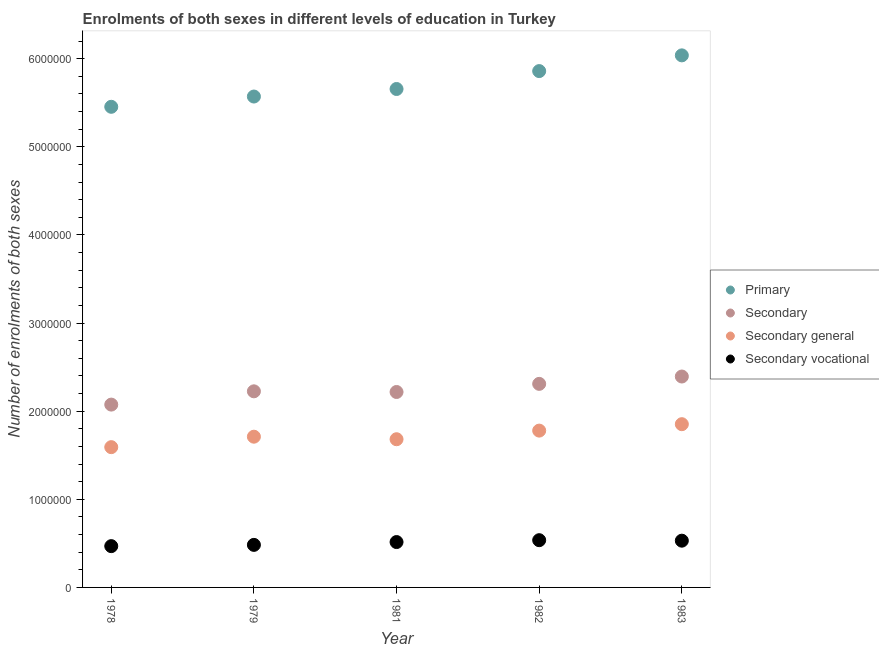How many different coloured dotlines are there?
Offer a very short reply. 4. Is the number of dotlines equal to the number of legend labels?
Make the answer very short. Yes. What is the number of enrolments in primary education in 1981?
Ensure brevity in your answer.  5.66e+06. Across all years, what is the maximum number of enrolments in primary education?
Give a very brief answer. 6.04e+06. Across all years, what is the minimum number of enrolments in secondary vocational education?
Your response must be concise. 4.69e+05. In which year was the number of enrolments in secondary education minimum?
Offer a terse response. 1978. What is the total number of enrolments in primary education in the graph?
Keep it short and to the point. 2.86e+07. What is the difference between the number of enrolments in secondary vocational education in 1978 and that in 1983?
Offer a very short reply. -6.19e+04. What is the difference between the number of enrolments in secondary vocational education in 1979 and the number of enrolments in secondary education in 1981?
Ensure brevity in your answer.  -1.74e+06. What is the average number of enrolments in secondary general education per year?
Your answer should be compact. 1.72e+06. In the year 1983, what is the difference between the number of enrolments in secondary education and number of enrolments in primary education?
Ensure brevity in your answer.  -3.64e+06. In how many years, is the number of enrolments in secondary vocational education greater than 1200000?
Make the answer very short. 0. What is the ratio of the number of enrolments in secondary vocational education in 1979 to that in 1982?
Give a very brief answer. 0.9. Is the difference between the number of enrolments in secondary vocational education in 1979 and 1982 greater than the difference between the number of enrolments in secondary education in 1979 and 1982?
Keep it short and to the point. Yes. What is the difference between the highest and the second highest number of enrolments in secondary general education?
Provide a succinct answer. 7.29e+04. What is the difference between the highest and the lowest number of enrolments in secondary vocational education?
Your answer should be compact. 6.75e+04. Is the sum of the number of enrolments in primary education in 1979 and 1982 greater than the maximum number of enrolments in secondary education across all years?
Your answer should be compact. Yes. Is the number of enrolments in secondary education strictly less than the number of enrolments in secondary general education over the years?
Give a very brief answer. No. How many years are there in the graph?
Provide a short and direct response. 5. Does the graph contain grids?
Keep it short and to the point. No. Where does the legend appear in the graph?
Your response must be concise. Center right. How many legend labels are there?
Your answer should be compact. 4. What is the title of the graph?
Provide a short and direct response. Enrolments of both sexes in different levels of education in Turkey. Does "Portugal" appear as one of the legend labels in the graph?
Keep it short and to the point. No. What is the label or title of the X-axis?
Give a very brief answer. Year. What is the label or title of the Y-axis?
Keep it short and to the point. Number of enrolments of both sexes. What is the Number of enrolments of both sexes in Primary in 1978?
Make the answer very short. 5.45e+06. What is the Number of enrolments of both sexes of Secondary in 1978?
Your response must be concise. 2.07e+06. What is the Number of enrolments of both sexes of Secondary general in 1978?
Offer a terse response. 1.59e+06. What is the Number of enrolments of both sexes in Secondary vocational in 1978?
Your answer should be very brief. 4.69e+05. What is the Number of enrolments of both sexes in Primary in 1979?
Your answer should be compact. 5.57e+06. What is the Number of enrolments of both sexes in Secondary in 1979?
Your response must be concise. 2.23e+06. What is the Number of enrolments of both sexes in Secondary general in 1979?
Offer a very short reply. 1.71e+06. What is the Number of enrolments of both sexes in Secondary vocational in 1979?
Provide a succinct answer. 4.83e+05. What is the Number of enrolments of both sexes of Primary in 1981?
Your answer should be very brief. 5.66e+06. What is the Number of enrolments of both sexes in Secondary in 1981?
Your response must be concise. 2.22e+06. What is the Number of enrolments of both sexes in Secondary general in 1981?
Your answer should be very brief. 1.68e+06. What is the Number of enrolments of both sexes in Secondary vocational in 1981?
Offer a very short reply. 5.15e+05. What is the Number of enrolments of both sexes in Primary in 1982?
Make the answer very short. 5.86e+06. What is the Number of enrolments of both sexes of Secondary in 1982?
Keep it short and to the point. 2.31e+06. What is the Number of enrolments of both sexes in Secondary general in 1982?
Provide a short and direct response. 1.78e+06. What is the Number of enrolments of both sexes in Secondary vocational in 1982?
Offer a very short reply. 5.36e+05. What is the Number of enrolments of both sexes of Primary in 1983?
Make the answer very short. 6.04e+06. What is the Number of enrolments of both sexes in Secondary in 1983?
Offer a very short reply. 2.39e+06. What is the Number of enrolments of both sexes in Secondary general in 1983?
Offer a terse response. 1.85e+06. What is the Number of enrolments of both sexes of Secondary vocational in 1983?
Provide a short and direct response. 5.30e+05. Across all years, what is the maximum Number of enrolments of both sexes in Primary?
Keep it short and to the point. 6.04e+06. Across all years, what is the maximum Number of enrolments of both sexes of Secondary?
Ensure brevity in your answer.  2.39e+06. Across all years, what is the maximum Number of enrolments of both sexes in Secondary general?
Your answer should be compact. 1.85e+06. Across all years, what is the maximum Number of enrolments of both sexes in Secondary vocational?
Offer a very short reply. 5.36e+05. Across all years, what is the minimum Number of enrolments of both sexes of Primary?
Your answer should be very brief. 5.45e+06. Across all years, what is the minimum Number of enrolments of both sexes in Secondary?
Your answer should be compact. 2.07e+06. Across all years, what is the minimum Number of enrolments of both sexes of Secondary general?
Keep it short and to the point. 1.59e+06. Across all years, what is the minimum Number of enrolments of both sexes of Secondary vocational?
Ensure brevity in your answer.  4.69e+05. What is the total Number of enrolments of both sexes in Primary in the graph?
Offer a very short reply. 2.86e+07. What is the total Number of enrolments of both sexes of Secondary in the graph?
Provide a short and direct response. 1.12e+07. What is the total Number of enrolments of both sexes of Secondary general in the graph?
Your answer should be very brief. 8.62e+06. What is the total Number of enrolments of both sexes of Secondary vocational in the graph?
Make the answer very short. 2.53e+06. What is the difference between the Number of enrolments of both sexes of Primary in 1978 and that in 1979?
Your answer should be compact. -1.17e+05. What is the difference between the Number of enrolments of both sexes of Secondary in 1978 and that in 1979?
Your response must be concise. -1.51e+05. What is the difference between the Number of enrolments of both sexes of Secondary general in 1978 and that in 1979?
Your answer should be compact. -1.19e+05. What is the difference between the Number of enrolments of both sexes of Secondary vocational in 1978 and that in 1979?
Your answer should be very brief. -1.43e+04. What is the difference between the Number of enrolments of both sexes of Primary in 1978 and that in 1981?
Offer a terse response. -2.02e+05. What is the difference between the Number of enrolments of both sexes in Secondary in 1978 and that in 1981?
Your answer should be compact. -1.43e+05. What is the difference between the Number of enrolments of both sexes of Secondary general in 1978 and that in 1981?
Make the answer very short. -8.99e+04. What is the difference between the Number of enrolments of both sexes in Secondary vocational in 1978 and that in 1981?
Provide a succinct answer. -4.64e+04. What is the difference between the Number of enrolments of both sexes in Primary in 1978 and that in 1982?
Offer a very short reply. -4.05e+05. What is the difference between the Number of enrolments of both sexes of Secondary in 1978 and that in 1982?
Offer a very short reply. -2.35e+05. What is the difference between the Number of enrolments of both sexes in Secondary general in 1978 and that in 1982?
Your answer should be compact. -1.88e+05. What is the difference between the Number of enrolments of both sexes of Secondary vocational in 1978 and that in 1982?
Provide a short and direct response. -6.75e+04. What is the difference between the Number of enrolments of both sexes of Primary in 1978 and that in 1983?
Give a very brief answer. -5.84e+05. What is the difference between the Number of enrolments of both sexes of Secondary in 1978 and that in 1983?
Offer a terse response. -3.19e+05. What is the difference between the Number of enrolments of both sexes of Secondary general in 1978 and that in 1983?
Your answer should be very brief. -2.61e+05. What is the difference between the Number of enrolments of both sexes in Secondary vocational in 1978 and that in 1983?
Make the answer very short. -6.19e+04. What is the difference between the Number of enrolments of both sexes of Primary in 1979 and that in 1981?
Offer a terse response. -8.56e+04. What is the difference between the Number of enrolments of both sexes of Secondary in 1979 and that in 1981?
Make the answer very short. 7624. What is the difference between the Number of enrolments of both sexes of Secondary general in 1979 and that in 1981?
Give a very brief answer. 2.88e+04. What is the difference between the Number of enrolments of both sexes of Secondary vocational in 1979 and that in 1981?
Offer a very short reply. -3.20e+04. What is the difference between the Number of enrolments of both sexes of Primary in 1979 and that in 1982?
Ensure brevity in your answer.  -2.89e+05. What is the difference between the Number of enrolments of both sexes of Secondary in 1979 and that in 1982?
Give a very brief answer. -8.46e+04. What is the difference between the Number of enrolments of both sexes in Secondary general in 1979 and that in 1982?
Your response must be concise. -6.90e+04. What is the difference between the Number of enrolments of both sexes of Secondary vocational in 1979 and that in 1982?
Provide a succinct answer. -5.32e+04. What is the difference between the Number of enrolments of both sexes of Primary in 1979 and that in 1983?
Give a very brief answer. -4.67e+05. What is the difference between the Number of enrolments of both sexes in Secondary in 1979 and that in 1983?
Provide a short and direct response. -1.68e+05. What is the difference between the Number of enrolments of both sexes in Secondary general in 1979 and that in 1983?
Make the answer very short. -1.42e+05. What is the difference between the Number of enrolments of both sexes in Secondary vocational in 1979 and that in 1983?
Your answer should be compact. -4.76e+04. What is the difference between the Number of enrolments of both sexes of Primary in 1981 and that in 1982?
Offer a very short reply. -2.03e+05. What is the difference between the Number of enrolments of both sexes in Secondary in 1981 and that in 1982?
Give a very brief answer. -9.22e+04. What is the difference between the Number of enrolments of both sexes of Secondary general in 1981 and that in 1982?
Provide a succinct answer. -9.78e+04. What is the difference between the Number of enrolments of both sexes of Secondary vocational in 1981 and that in 1982?
Make the answer very short. -2.12e+04. What is the difference between the Number of enrolments of both sexes in Primary in 1981 and that in 1983?
Offer a terse response. -3.82e+05. What is the difference between the Number of enrolments of both sexes of Secondary in 1981 and that in 1983?
Give a very brief answer. -1.76e+05. What is the difference between the Number of enrolments of both sexes of Secondary general in 1981 and that in 1983?
Ensure brevity in your answer.  -1.71e+05. What is the difference between the Number of enrolments of both sexes in Secondary vocational in 1981 and that in 1983?
Provide a short and direct response. -1.56e+04. What is the difference between the Number of enrolments of both sexes of Primary in 1982 and that in 1983?
Offer a very short reply. -1.78e+05. What is the difference between the Number of enrolments of both sexes in Secondary in 1982 and that in 1983?
Provide a short and direct response. -8.34e+04. What is the difference between the Number of enrolments of both sexes of Secondary general in 1982 and that in 1983?
Make the answer very short. -7.29e+04. What is the difference between the Number of enrolments of both sexes of Secondary vocational in 1982 and that in 1983?
Your answer should be compact. 5622. What is the difference between the Number of enrolments of both sexes in Primary in 1978 and the Number of enrolments of both sexes in Secondary in 1979?
Provide a succinct answer. 3.23e+06. What is the difference between the Number of enrolments of both sexes of Primary in 1978 and the Number of enrolments of both sexes of Secondary general in 1979?
Give a very brief answer. 3.74e+06. What is the difference between the Number of enrolments of both sexes of Primary in 1978 and the Number of enrolments of both sexes of Secondary vocational in 1979?
Your answer should be very brief. 4.97e+06. What is the difference between the Number of enrolments of both sexes in Secondary in 1978 and the Number of enrolments of both sexes in Secondary general in 1979?
Your answer should be very brief. 3.64e+05. What is the difference between the Number of enrolments of both sexes in Secondary in 1978 and the Number of enrolments of both sexes in Secondary vocational in 1979?
Your answer should be very brief. 1.59e+06. What is the difference between the Number of enrolments of both sexes of Secondary general in 1978 and the Number of enrolments of both sexes of Secondary vocational in 1979?
Offer a very short reply. 1.11e+06. What is the difference between the Number of enrolments of both sexes in Primary in 1978 and the Number of enrolments of both sexes in Secondary in 1981?
Ensure brevity in your answer.  3.24e+06. What is the difference between the Number of enrolments of both sexes in Primary in 1978 and the Number of enrolments of both sexes in Secondary general in 1981?
Offer a terse response. 3.77e+06. What is the difference between the Number of enrolments of both sexes in Primary in 1978 and the Number of enrolments of both sexes in Secondary vocational in 1981?
Provide a succinct answer. 4.94e+06. What is the difference between the Number of enrolments of both sexes in Secondary in 1978 and the Number of enrolments of both sexes in Secondary general in 1981?
Offer a terse response. 3.93e+05. What is the difference between the Number of enrolments of both sexes of Secondary in 1978 and the Number of enrolments of both sexes of Secondary vocational in 1981?
Make the answer very short. 1.56e+06. What is the difference between the Number of enrolments of both sexes in Secondary general in 1978 and the Number of enrolments of both sexes in Secondary vocational in 1981?
Provide a short and direct response. 1.08e+06. What is the difference between the Number of enrolments of both sexes in Primary in 1978 and the Number of enrolments of both sexes in Secondary in 1982?
Your answer should be compact. 3.14e+06. What is the difference between the Number of enrolments of both sexes in Primary in 1978 and the Number of enrolments of both sexes in Secondary general in 1982?
Your response must be concise. 3.67e+06. What is the difference between the Number of enrolments of both sexes in Primary in 1978 and the Number of enrolments of both sexes in Secondary vocational in 1982?
Your answer should be very brief. 4.92e+06. What is the difference between the Number of enrolments of both sexes in Secondary in 1978 and the Number of enrolments of both sexes in Secondary general in 1982?
Your answer should be compact. 2.95e+05. What is the difference between the Number of enrolments of both sexes of Secondary in 1978 and the Number of enrolments of both sexes of Secondary vocational in 1982?
Give a very brief answer. 1.54e+06. What is the difference between the Number of enrolments of both sexes in Secondary general in 1978 and the Number of enrolments of both sexes in Secondary vocational in 1982?
Provide a short and direct response. 1.06e+06. What is the difference between the Number of enrolments of both sexes in Primary in 1978 and the Number of enrolments of both sexes in Secondary in 1983?
Your answer should be compact. 3.06e+06. What is the difference between the Number of enrolments of both sexes in Primary in 1978 and the Number of enrolments of both sexes in Secondary general in 1983?
Make the answer very short. 3.60e+06. What is the difference between the Number of enrolments of both sexes in Primary in 1978 and the Number of enrolments of both sexes in Secondary vocational in 1983?
Provide a succinct answer. 4.92e+06. What is the difference between the Number of enrolments of both sexes of Secondary in 1978 and the Number of enrolments of both sexes of Secondary general in 1983?
Offer a very short reply. 2.22e+05. What is the difference between the Number of enrolments of both sexes in Secondary in 1978 and the Number of enrolments of both sexes in Secondary vocational in 1983?
Provide a succinct answer. 1.54e+06. What is the difference between the Number of enrolments of both sexes of Secondary general in 1978 and the Number of enrolments of both sexes of Secondary vocational in 1983?
Your response must be concise. 1.06e+06. What is the difference between the Number of enrolments of both sexes of Primary in 1979 and the Number of enrolments of both sexes of Secondary in 1981?
Offer a very short reply. 3.35e+06. What is the difference between the Number of enrolments of both sexes in Primary in 1979 and the Number of enrolments of both sexes in Secondary general in 1981?
Provide a succinct answer. 3.89e+06. What is the difference between the Number of enrolments of both sexes of Primary in 1979 and the Number of enrolments of both sexes of Secondary vocational in 1981?
Offer a terse response. 5.06e+06. What is the difference between the Number of enrolments of both sexes of Secondary in 1979 and the Number of enrolments of both sexes of Secondary general in 1981?
Keep it short and to the point. 5.44e+05. What is the difference between the Number of enrolments of both sexes in Secondary in 1979 and the Number of enrolments of both sexes in Secondary vocational in 1981?
Your response must be concise. 1.71e+06. What is the difference between the Number of enrolments of both sexes of Secondary general in 1979 and the Number of enrolments of both sexes of Secondary vocational in 1981?
Your answer should be compact. 1.20e+06. What is the difference between the Number of enrolments of both sexes of Primary in 1979 and the Number of enrolments of both sexes of Secondary in 1982?
Provide a short and direct response. 3.26e+06. What is the difference between the Number of enrolments of both sexes in Primary in 1979 and the Number of enrolments of both sexes in Secondary general in 1982?
Ensure brevity in your answer.  3.79e+06. What is the difference between the Number of enrolments of both sexes of Primary in 1979 and the Number of enrolments of both sexes of Secondary vocational in 1982?
Your answer should be compact. 5.03e+06. What is the difference between the Number of enrolments of both sexes in Secondary in 1979 and the Number of enrolments of both sexes in Secondary general in 1982?
Your response must be concise. 4.46e+05. What is the difference between the Number of enrolments of both sexes of Secondary in 1979 and the Number of enrolments of both sexes of Secondary vocational in 1982?
Ensure brevity in your answer.  1.69e+06. What is the difference between the Number of enrolments of both sexes of Secondary general in 1979 and the Number of enrolments of both sexes of Secondary vocational in 1982?
Keep it short and to the point. 1.17e+06. What is the difference between the Number of enrolments of both sexes of Primary in 1979 and the Number of enrolments of both sexes of Secondary in 1983?
Offer a very short reply. 3.18e+06. What is the difference between the Number of enrolments of both sexes of Primary in 1979 and the Number of enrolments of both sexes of Secondary general in 1983?
Your response must be concise. 3.72e+06. What is the difference between the Number of enrolments of both sexes in Primary in 1979 and the Number of enrolments of both sexes in Secondary vocational in 1983?
Provide a succinct answer. 5.04e+06. What is the difference between the Number of enrolments of both sexes in Secondary in 1979 and the Number of enrolments of both sexes in Secondary general in 1983?
Make the answer very short. 3.73e+05. What is the difference between the Number of enrolments of both sexes in Secondary in 1979 and the Number of enrolments of both sexes in Secondary vocational in 1983?
Give a very brief answer. 1.70e+06. What is the difference between the Number of enrolments of both sexes of Secondary general in 1979 and the Number of enrolments of both sexes of Secondary vocational in 1983?
Give a very brief answer. 1.18e+06. What is the difference between the Number of enrolments of both sexes in Primary in 1981 and the Number of enrolments of both sexes in Secondary in 1982?
Offer a terse response. 3.35e+06. What is the difference between the Number of enrolments of both sexes of Primary in 1981 and the Number of enrolments of both sexes of Secondary general in 1982?
Make the answer very short. 3.88e+06. What is the difference between the Number of enrolments of both sexes in Primary in 1981 and the Number of enrolments of both sexes in Secondary vocational in 1982?
Keep it short and to the point. 5.12e+06. What is the difference between the Number of enrolments of both sexes of Secondary in 1981 and the Number of enrolments of both sexes of Secondary general in 1982?
Your answer should be compact. 4.38e+05. What is the difference between the Number of enrolments of both sexes of Secondary in 1981 and the Number of enrolments of both sexes of Secondary vocational in 1982?
Provide a succinct answer. 1.68e+06. What is the difference between the Number of enrolments of both sexes in Secondary general in 1981 and the Number of enrolments of both sexes in Secondary vocational in 1982?
Provide a succinct answer. 1.15e+06. What is the difference between the Number of enrolments of both sexes in Primary in 1981 and the Number of enrolments of both sexes in Secondary in 1983?
Provide a short and direct response. 3.26e+06. What is the difference between the Number of enrolments of both sexes in Primary in 1981 and the Number of enrolments of both sexes in Secondary general in 1983?
Provide a short and direct response. 3.80e+06. What is the difference between the Number of enrolments of both sexes in Primary in 1981 and the Number of enrolments of both sexes in Secondary vocational in 1983?
Give a very brief answer. 5.13e+06. What is the difference between the Number of enrolments of both sexes of Secondary in 1981 and the Number of enrolments of both sexes of Secondary general in 1983?
Ensure brevity in your answer.  3.65e+05. What is the difference between the Number of enrolments of both sexes of Secondary in 1981 and the Number of enrolments of both sexes of Secondary vocational in 1983?
Ensure brevity in your answer.  1.69e+06. What is the difference between the Number of enrolments of both sexes in Secondary general in 1981 and the Number of enrolments of both sexes in Secondary vocational in 1983?
Your response must be concise. 1.15e+06. What is the difference between the Number of enrolments of both sexes in Primary in 1982 and the Number of enrolments of both sexes in Secondary in 1983?
Your answer should be compact. 3.47e+06. What is the difference between the Number of enrolments of both sexes of Primary in 1982 and the Number of enrolments of both sexes of Secondary general in 1983?
Keep it short and to the point. 4.01e+06. What is the difference between the Number of enrolments of both sexes in Primary in 1982 and the Number of enrolments of both sexes in Secondary vocational in 1983?
Provide a short and direct response. 5.33e+06. What is the difference between the Number of enrolments of both sexes in Secondary in 1982 and the Number of enrolments of both sexes in Secondary general in 1983?
Offer a very short reply. 4.58e+05. What is the difference between the Number of enrolments of both sexes in Secondary in 1982 and the Number of enrolments of both sexes in Secondary vocational in 1983?
Offer a terse response. 1.78e+06. What is the difference between the Number of enrolments of both sexes in Secondary general in 1982 and the Number of enrolments of both sexes in Secondary vocational in 1983?
Ensure brevity in your answer.  1.25e+06. What is the average Number of enrolments of both sexes in Primary per year?
Your answer should be compact. 5.72e+06. What is the average Number of enrolments of both sexes in Secondary per year?
Your answer should be very brief. 2.24e+06. What is the average Number of enrolments of both sexes in Secondary general per year?
Provide a succinct answer. 1.72e+06. What is the average Number of enrolments of both sexes of Secondary vocational per year?
Your response must be concise. 5.07e+05. In the year 1978, what is the difference between the Number of enrolments of both sexes in Primary and Number of enrolments of both sexes in Secondary?
Offer a terse response. 3.38e+06. In the year 1978, what is the difference between the Number of enrolments of both sexes in Primary and Number of enrolments of both sexes in Secondary general?
Ensure brevity in your answer.  3.86e+06. In the year 1978, what is the difference between the Number of enrolments of both sexes of Primary and Number of enrolments of both sexes of Secondary vocational?
Offer a very short reply. 4.99e+06. In the year 1978, what is the difference between the Number of enrolments of both sexes in Secondary and Number of enrolments of both sexes in Secondary general?
Your answer should be compact. 4.83e+05. In the year 1978, what is the difference between the Number of enrolments of both sexes of Secondary and Number of enrolments of both sexes of Secondary vocational?
Your answer should be very brief. 1.61e+06. In the year 1978, what is the difference between the Number of enrolments of both sexes of Secondary general and Number of enrolments of both sexes of Secondary vocational?
Give a very brief answer. 1.12e+06. In the year 1979, what is the difference between the Number of enrolments of both sexes of Primary and Number of enrolments of both sexes of Secondary?
Your response must be concise. 3.35e+06. In the year 1979, what is the difference between the Number of enrolments of both sexes in Primary and Number of enrolments of both sexes in Secondary general?
Ensure brevity in your answer.  3.86e+06. In the year 1979, what is the difference between the Number of enrolments of both sexes of Primary and Number of enrolments of both sexes of Secondary vocational?
Offer a terse response. 5.09e+06. In the year 1979, what is the difference between the Number of enrolments of both sexes in Secondary and Number of enrolments of both sexes in Secondary general?
Your answer should be compact. 5.15e+05. In the year 1979, what is the difference between the Number of enrolments of both sexes in Secondary and Number of enrolments of both sexes in Secondary vocational?
Your answer should be very brief. 1.74e+06. In the year 1979, what is the difference between the Number of enrolments of both sexes of Secondary general and Number of enrolments of both sexes of Secondary vocational?
Make the answer very short. 1.23e+06. In the year 1981, what is the difference between the Number of enrolments of both sexes of Primary and Number of enrolments of both sexes of Secondary?
Keep it short and to the point. 3.44e+06. In the year 1981, what is the difference between the Number of enrolments of both sexes in Primary and Number of enrolments of both sexes in Secondary general?
Make the answer very short. 3.97e+06. In the year 1981, what is the difference between the Number of enrolments of both sexes in Primary and Number of enrolments of both sexes in Secondary vocational?
Give a very brief answer. 5.14e+06. In the year 1981, what is the difference between the Number of enrolments of both sexes in Secondary and Number of enrolments of both sexes in Secondary general?
Your response must be concise. 5.36e+05. In the year 1981, what is the difference between the Number of enrolments of both sexes of Secondary and Number of enrolments of both sexes of Secondary vocational?
Provide a short and direct response. 1.70e+06. In the year 1981, what is the difference between the Number of enrolments of both sexes in Secondary general and Number of enrolments of both sexes in Secondary vocational?
Ensure brevity in your answer.  1.17e+06. In the year 1982, what is the difference between the Number of enrolments of both sexes in Primary and Number of enrolments of both sexes in Secondary?
Offer a very short reply. 3.55e+06. In the year 1982, what is the difference between the Number of enrolments of both sexes of Primary and Number of enrolments of both sexes of Secondary general?
Your response must be concise. 4.08e+06. In the year 1982, what is the difference between the Number of enrolments of both sexes of Primary and Number of enrolments of both sexes of Secondary vocational?
Ensure brevity in your answer.  5.32e+06. In the year 1982, what is the difference between the Number of enrolments of both sexes in Secondary and Number of enrolments of both sexes in Secondary general?
Your answer should be compact. 5.30e+05. In the year 1982, what is the difference between the Number of enrolments of both sexes of Secondary and Number of enrolments of both sexes of Secondary vocational?
Provide a succinct answer. 1.77e+06. In the year 1982, what is the difference between the Number of enrolments of both sexes of Secondary general and Number of enrolments of both sexes of Secondary vocational?
Make the answer very short. 1.24e+06. In the year 1983, what is the difference between the Number of enrolments of both sexes in Primary and Number of enrolments of both sexes in Secondary?
Offer a very short reply. 3.64e+06. In the year 1983, what is the difference between the Number of enrolments of both sexes in Primary and Number of enrolments of both sexes in Secondary general?
Keep it short and to the point. 4.19e+06. In the year 1983, what is the difference between the Number of enrolments of both sexes of Primary and Number of enrolments of both sexes of Secondary vocational?
Offer a terse response. 5.51e+06. In the year 1983, what is the difference between the Number of enrolments of both sexes in Secondary and Number of enrolments of both sexes in Secondary general?
Your answer should be very brief. 5.41e+05. In the year 1983, what is the difference between the Number of enrolments of both sexes in Secondary and Number of enrolments of both sexes in Secondary vocational?
Your answer should be very brief. 1.86e+06. In the year 1983, what is the difference between the Number of enrolments of both sexes in Secondary general and Number of enrolments of both sexes in Secondary vocational?
Provide a short and direct response. 1.32e+06. What is the ratio of the Number of enrolments of both sexes of Primary in 1978 to that in 1979?
Offer a terse response. 0.98. What is the ratio of the Number of enrolments of both sexes of Secondary in 1978 to that in 1979?
Offer a terse response. 0.93. What is the ratio of the Number of enrolments of both sexes of Secondary general in 1978 to that in 1979?
Provide a short and direct response. 0.93. What is the ratio of the Number of enrolments of both sexes of Secondary vocational in 1978 to that in 1979?
Offer a very short reply. 0.97. What is the ratio of the Number of enrolments of both sexes of Secondary in 1978 to that in 1981?
Give a very brief answer. 0.94. What is the ratio of the Number of enrolments of both sexes of Secondary general in 1978 to that in 1981?
Provide a succinct answer. 0.95. What is the ratio of the Number of enrolments of both sexes of Secondary vocational in 1978 to that in 1981?
Your answer should be very brief. 0.91. What is the ratio of the Number of enrolments of both sexes of Primary in 1978 to that in 1982?
Your answer should be compact. 0.93. What is the ratio of the Number of enrolments of both sexes of Secondary in 1978 to that in 1982?
Provide a succinct answer. 0.9. What is the ratio of the Number of enrolments of both sexes of Secondary general in 1978 to that in 1982?
Keep it short and to the point. 0.89. What is the ratio of the Number of enrolments of both sexes in Secondary vocational in 1978 to that in 1982?
Your answer should be compact. 0.87. What is the ratio of the Number of enrolments of both sexes of Primary in 1978 to that in 1983?
Your response must be concise. 0.9. What is the ratio of the Number of enrolments of both sexes of Secondary in 1978 to that in 1983?
Provide a succinct answer. 0.87. What is the ratio of the Number of enrolments of both sexes in Secondary general in 1978 to that in 1983?
Offer a very short reply. 0.86. What is the ratio of the Number of enrolments of both sexes in Secondary vocational in 1978 to that in 1983?
Make the answer very short. 0.88. What is the ratio of the Number of enrolments of both sexes of Primary in 1979 to that in 1981?
Offer a very short reply. 0.98. What is the ratio of the Number of enrolments of both sexes of Secondary in 1979 to that in 1981?
Ensure brevity in your answer.  1. What is the ratio of the Number of enrolments of both sexes in Secondary general in 1979 to that in 1981?
Provide a short and direct response. 1.02. What is the ratio of the Number of enrolments of both sexes of Secondary vocational in 1979 to that in 1981?
Provide a short and direct response. 0.94. What is the ratio of the Number of enrolments of both sexes in Primary in 1979 to that in 1982?
Your answer should be very brief. 0.95. What is the ratio of the Number of enrolments of both sexes in Secondary in 1979 to that in 1982?
Provide a succinct answer. 0.96. What is the ratio of the Number of enrolments of both sexes in Secondary general in 1979 to that in 1982?
Ensure brevity in your answer.  0.96. What is the ratio of the Number of enrolments of both sexes of Secondary vocational in 1979 to that in 1982?
Make the answer very short. 0.9. What is the ratio of the Number of enrolments of both sexes of Primary in 1979 to that in 1983?
Keep it short and to the point. 0.92. What is the ratio of the Number of enrolments of both sexes in Secondary in 1979 to that in 1983?
Offer a very short reply. 0.93. What is the ratio of the Number of enrolments of both sexes of Secondary general in 1979 to that in 1983?
Ensure brevity in your answer.  0.92. What is the ratio of the Number of enrolments of both sexes of Secondary vocational in 1979 to that in 1983?
Offer a terse response. 0.91. What is the ratio of the Number of enrolments of both sexes of Primary in 1981 to that in 1982?
Offer a very short reply. 0.97. What is the ratio of the Number of enrolments of both sexes in Secondary in 1981 to that in 1982?
Your response must be concise. 0.96. What is the ratio of the Number of enrolments of both sexes in Secondary general in 1981 to that in 1982?
Provide a short and direct response. 0.94. What is the ratio of the Number of enrolments of both sexes in Secondary vocational in 1981 to that in 1982?
Offer a terse response. 0.96. What is the ratio of the Number of enrolments of both sexes in Primary in 1981 to that in 1983?
Keep it short and to the point. 0.94. What is the ratio of the Number of enrolments of both sexes in Secondary in 1981 to that in 1983?
Your response must be concise. 0.93. What is the ratio of the Number of enrolments of both sexes of Secondary general in 1981 to that in 1983?
Give a very brief answer. 0.91. What is the ratio of the Number of enrolments of both sexes of Secondary vocational in 1981 to that in 1983?
Offer a very short reply. 0.97. What is the ratio of the Number of enrolments of both sexes of Primary in 1982 to that in 1983?
Your answer should be very brief. 0.97. What is the ratio of the Number of enrolments of both sexes in Secondary in 1982 to that in 1983?
Your answer should be very brief. 0.97. What is the ratio of the Number of enrolments of both sexes in Secondary general in 1982 to that in 1983?
Your response must be concise. 0.96. What is the ratio of the Number of enrolments of both sexes in Secondary vocational in 1982 to that in 1983?
Ensure brevity in your answer.  1.01. What is the difference between the highest and the second highest Number of enrolments of both sexes of Primary?
Offer a very short reply. 1.78e+05. What is the difference between the highest and the second highest Number of enrolments of both sexes of Secondary?
Keep it short and to the point. 8.34e+04. What is the difference between the highest and the second highest Number of enrolments of both sexes in Secondary general?
Keep it short and to the point. 7.29e+04. What is the difference between the highest and the second highest Number of enrolments of both sexes of Secondary vocational?
Ensure brevity in your answer.  5622. What is the difference between the highest and the lowest Number of enrolments of both sexes of Primary?
Give a very brief answer. 5.84e+05. What is the difference between the highest and the lowest Number of enrolments of both sexes of Secondary?
Provide a short and direct response. 3.19e+05. What is the difference between the highest and the lowest Number of enrolments of both sexes of Secondary general?
Your answer should be compact. 2.61e+05. What is the difference between the highest and the lowest Number of enrolments of both sexes in Secondary vocational?
Your answer should be compact. 6.75e+04. 